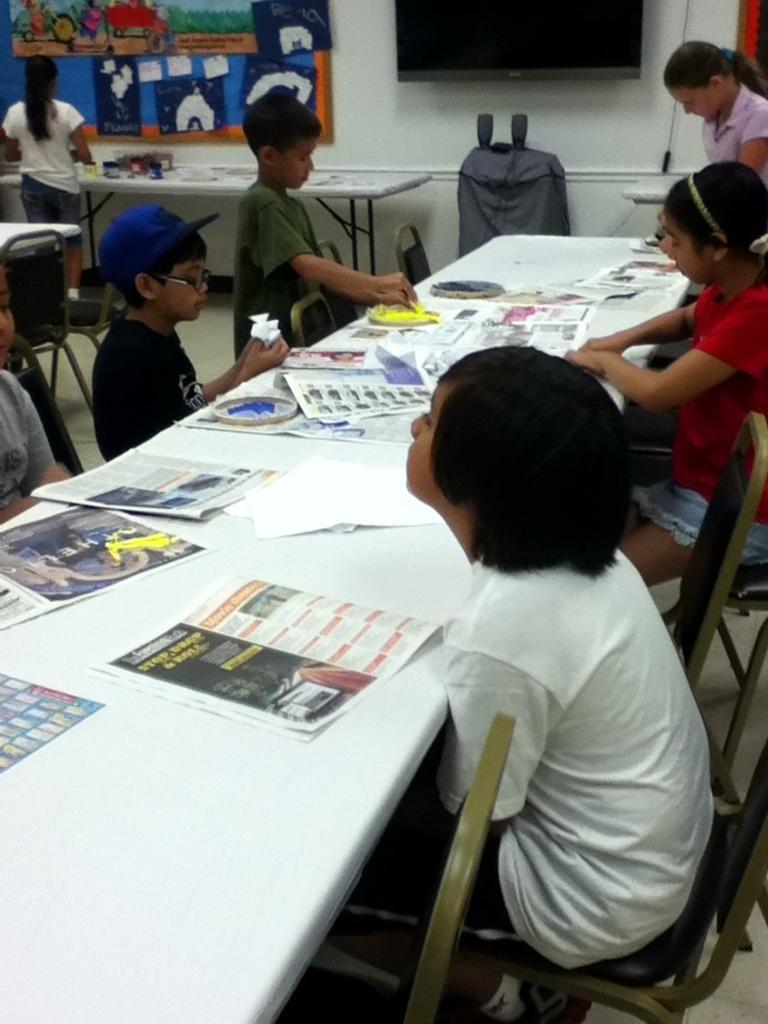In one or two sentences, can you explain what this image depicts? We can see board and few posters , television over a wall. Here on the table we can see newspapers, papers and painting trays. We can see students sitting and standing in front of a table. This is a floor. Here we can see a bag. 